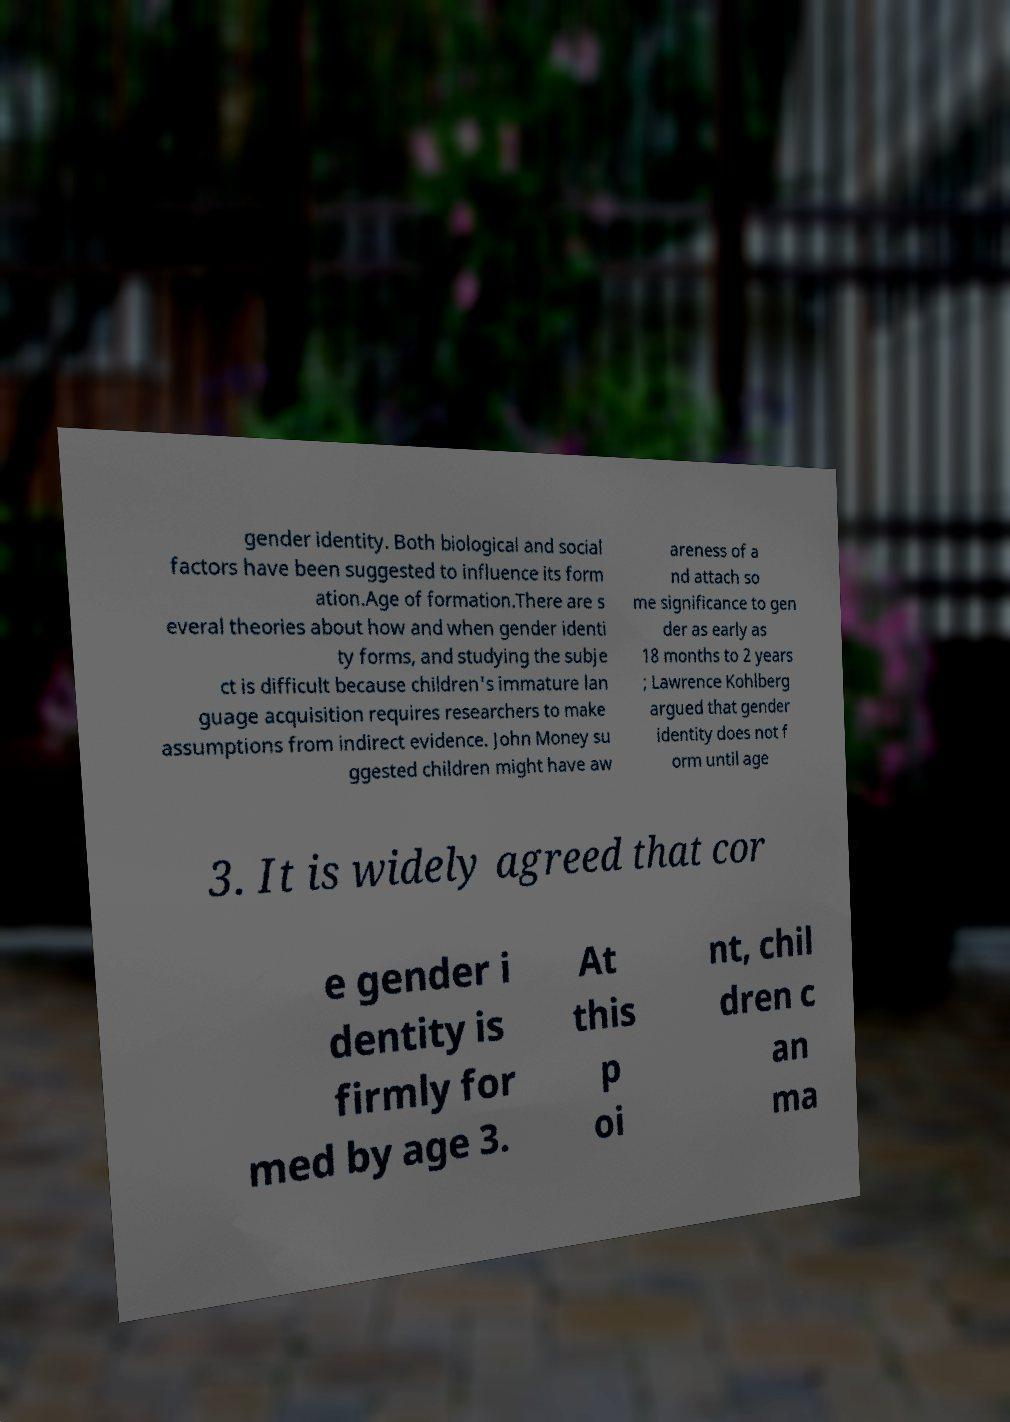There's text embedded in this image that I need extracted. Can you transcribe it verbatim? gender identity. Both biological and social factors have been suggested to influence its form ation.Age of formation.There are s everal theories about how and when gender identi ty forms, and studying the subje ct is difficult because children's immature lan guage acquisition requires researchers to make assumptions from indirect evidence. John Money su ggested children might have aw areness of a nd attach so me significance to gen der as early as 18 months to 2 years ; Lawrence Kohlberg argued that gender identity does not f orm until age 3. It is widely agreed that cor e gender i dentity is firmly for med by age 3. At this p oi nt, chil dren c an ma 